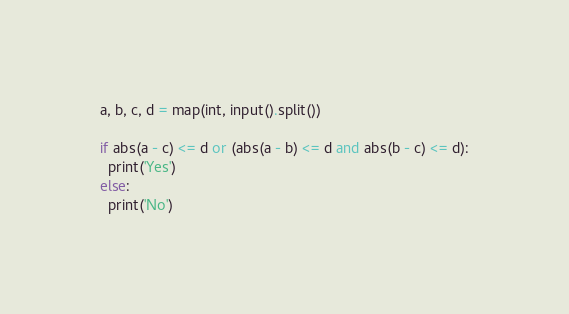Convert code to text. <code><loc_0><loc_0><loc_500><loc_500><_Python_>a, b, c, d = map(int, input().split())
 
if abs(a - c) <= d or (abs(a - b) <= d and abs(b - c) <= d):
  print('Yes')
else:
  print('No')</code> 